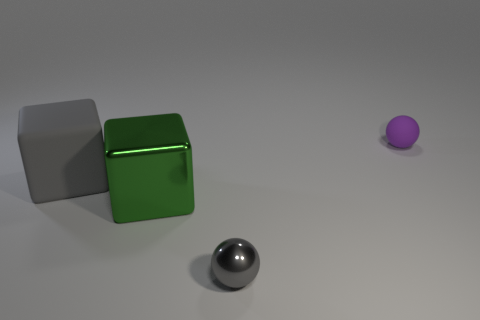Subtract all gray blocks. How many blocks are left? 1 Add 2 small shiny spheres. How many objects exist? 6 Subtract all purple balls. How many cyan cubes are left? 0 Subtract 0 red balls. How many objects are left? 4 Subtract 1 blocks. How many blocks are left? 1 Subtract all yellow spheres. Subtract all brown blocks. How many spheres are left? 2 Subtract all tiny rubber objects. Subtract all matte balls. How many objects are left? 2 Add 3 large gray blocks. How many large gray blocks are left? 4 Add 2 purple things. How many purple things exist? 3 